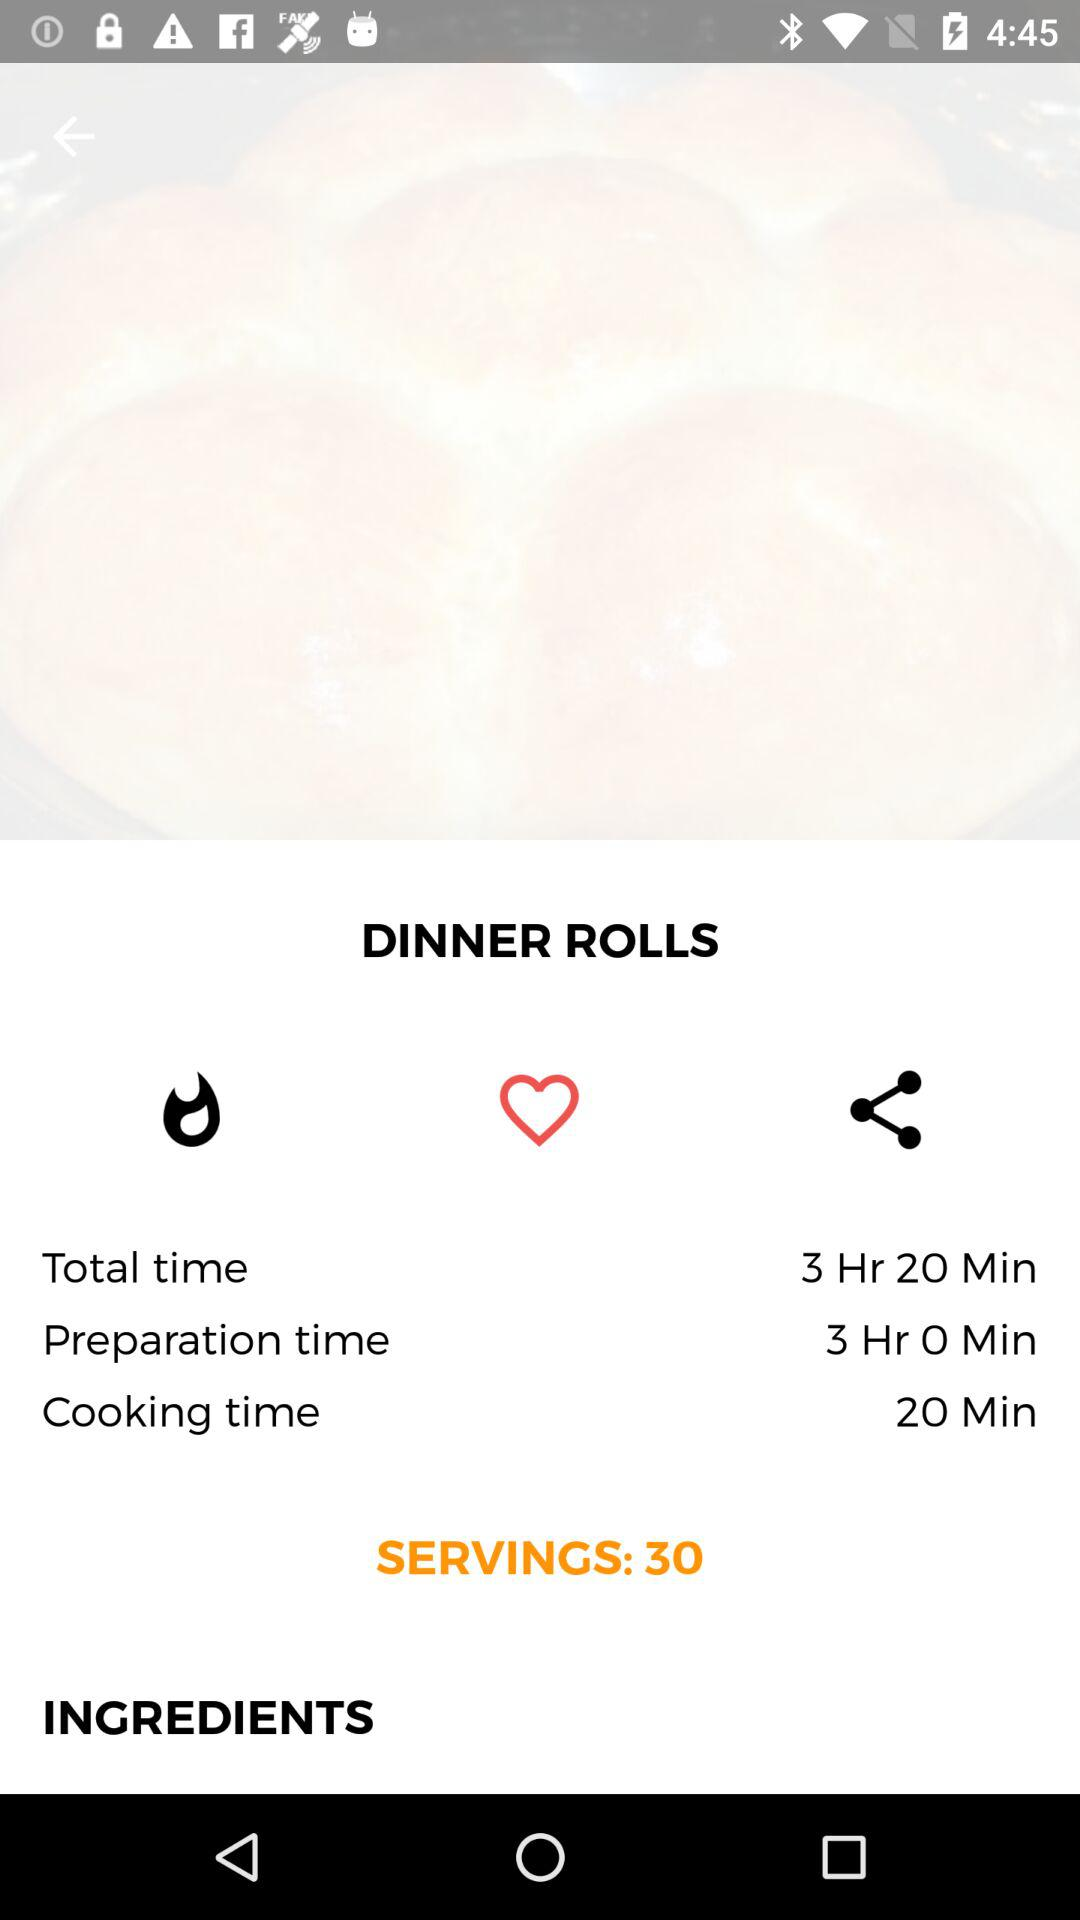How long does it take in total to make dinner rolls? It takes 3 hours 20 minutes to make dinner rolls. 